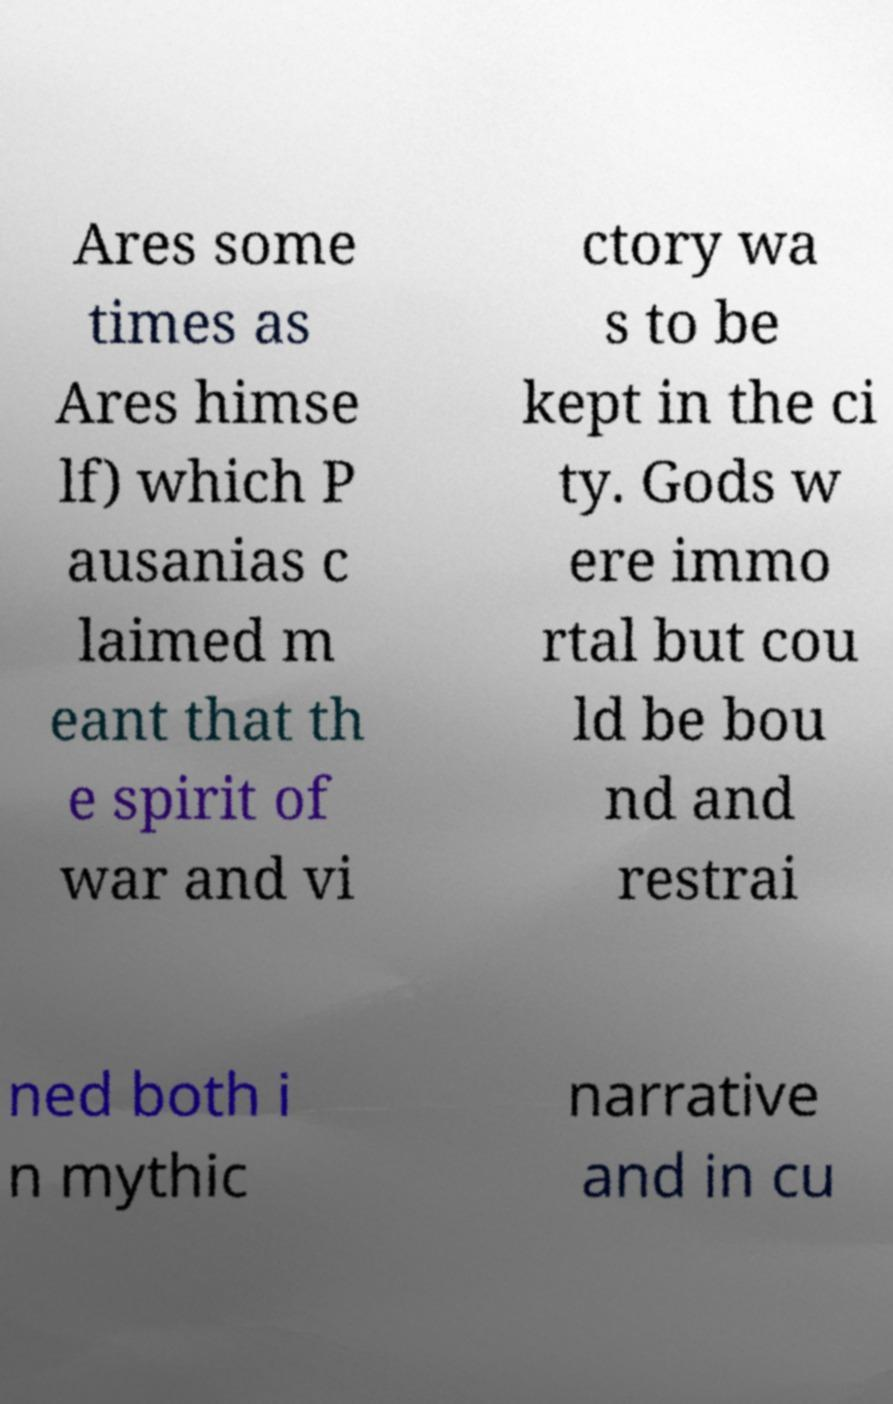Please read and relay the text visible in this image. What does it say? Ares some times as Ares himse lf) which P ausanias c laimed m eant that th e spirit of war and vi ctory wa s to be kept in the ci ty. Gods w ere immo rtal but cou ld be bou nd and restrai ned both i n mythic narrative and in cu 